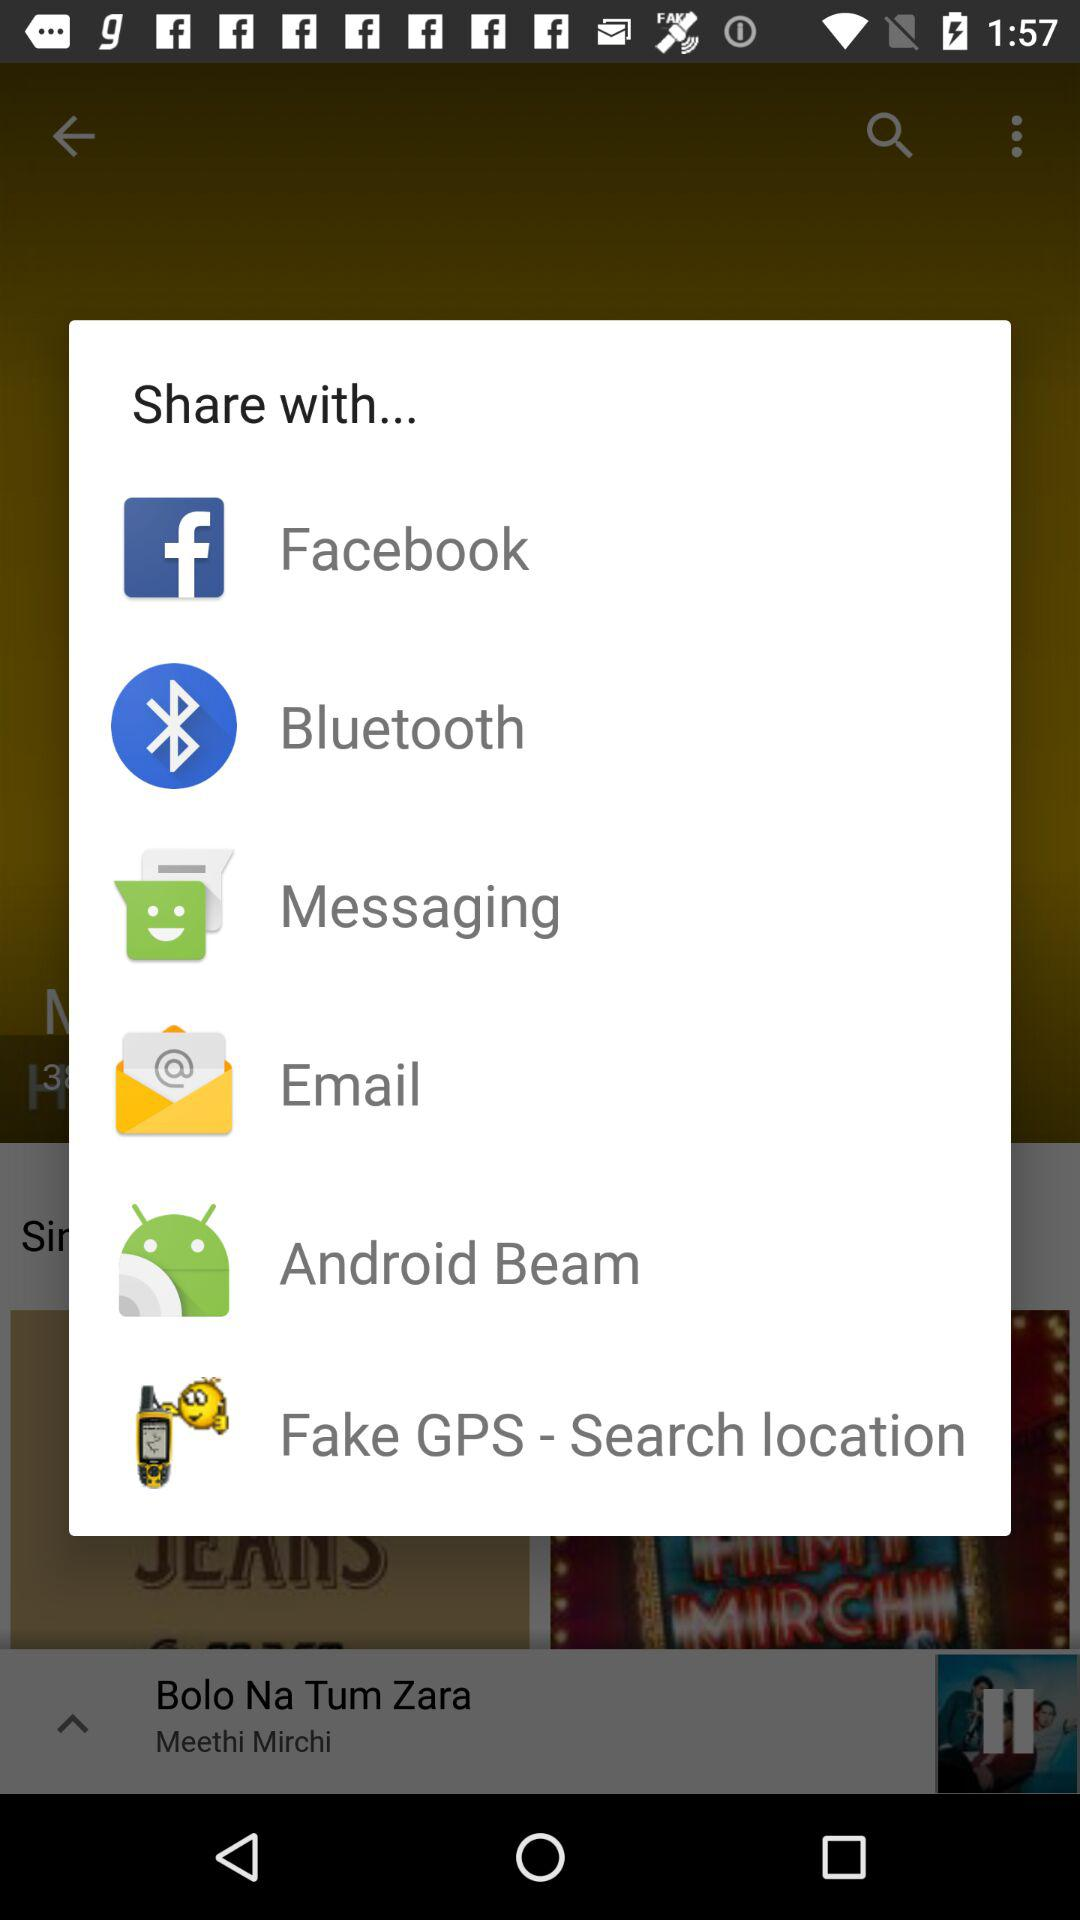What are the different applications through which we can share? You can share through "Facebook", "Bluetooth", "Messaging", "Email", "Android Beam" and "Fake GPS - Search location". 